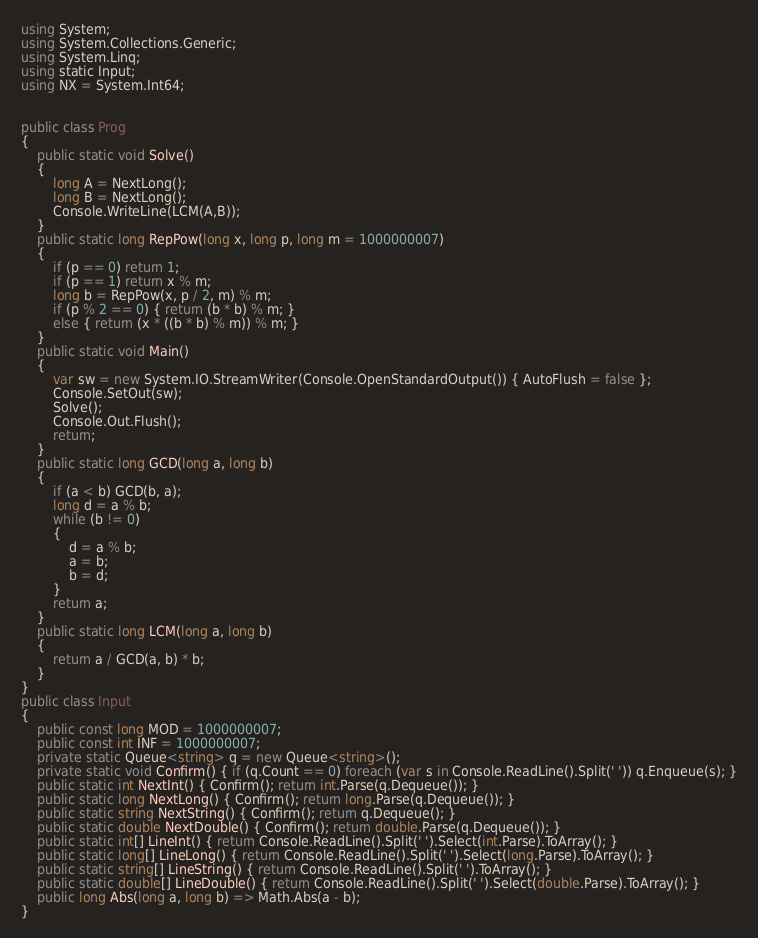Convert code to text. <code><loc_0><loc_0><loc_500><loc_500><_C#_>using System;
using System.Collections.Generic;
using System.Linq;
using static Input;
using NX = System.Int64;


public class Prog
{
    public static void Solve()
    {
        long A = NextLong();
        long B = NextLong();
        Console.WriteLine(LCM(A,B));
    }
    public static long RepPow(long x, long p, long m = 1000000007)
    {
        if (p == 0) return 1;
        if (p == 1) return x % m;
        long b = RepPow(x, p / 2, m) % m;
        if (p % 2 == 0) { return (b * b) % m; }
        else { return (x * ((b * b) % m)) % m; }
    }
    public static void Main()
    {
        var sw = new System.IO.StreamWriter(Console.OpenStandardOutput()) { AutoFlush = false };
        Console.SetOut(sw);
        Solve();
        Console.Out.Flush();
        return;
    }
    public static long GCD(long a, long b)
    {
        if (a < b) GCD(b, a);
        long d = a % b;
        while (b != 0)
        {
            d = a % b;
            a = b;
            b = d;
        }
        return a;
    }
    public static long LCM(long a, long b)
    {
        return a / GCD(a, b) * b;
    }
}
public class Input
{
    public const long MOD = 1000000007;
    public const int INF = 1000000007;
    private static Queue<string> q = new Queue<string>();
    private static void Confirm() { if (q.Count == 0) foreach (var s in Console.ReadLine().Split(' ')) q.Enqueue(s); }
    public static int NextInt() { Confirm(); return int.Parse(q.Dequeue()); }
    public static long NextLong() { Confirm(); return long.Parse(q.Dequeue()); }
    public static string NextString() { Confirm(); return q.Dequeue(); }
    public static double NextDouble() { Confirm(); return double.Parse(q.Dequeue()); }
    public static int[] LineInt() { return Console.ReadLine().Split(' ').Select(int.Parse).ToArray(); }
    public static long[] LineLong() { return Console.ReadLine().Split(' ').Select(long.Parse).ToArray(); }
    public static string[] LineString() { return Console.ReadLine().Split(' ').ToArray(); }
    public static double[] LineDouble() { return Console.ReadLine().Split(' ').Select(double.Parse).ToArray(); }
    public long Abs(long a, long b) => Math.Abs(a - b);
}
</code> 